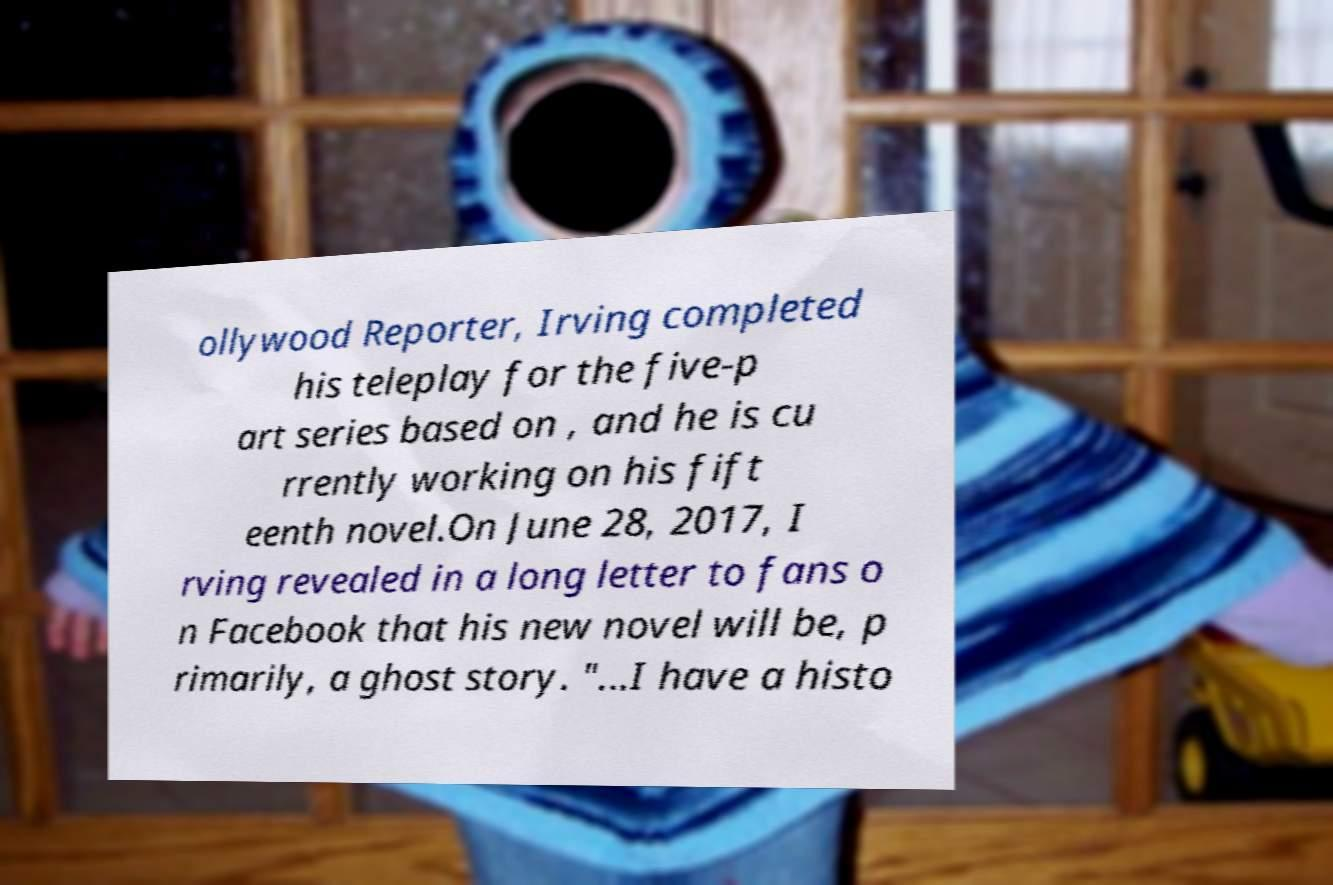Can you accurately transcribe the text from the provided image for me? ollywood Reporter, Irving completed his teleplay for the five-p art series based on , and he is cu rrently working on his fift eenth novel.On June 28, 2017, I rving revealed in a long letter to fans o n Facebook that his new novel will be, p rimarily, a ghost story. "...I have a histo 